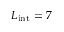<formula> <loc_0><loc_0><loc_500><loc_500>L _ { i n t } = 7</formula> 